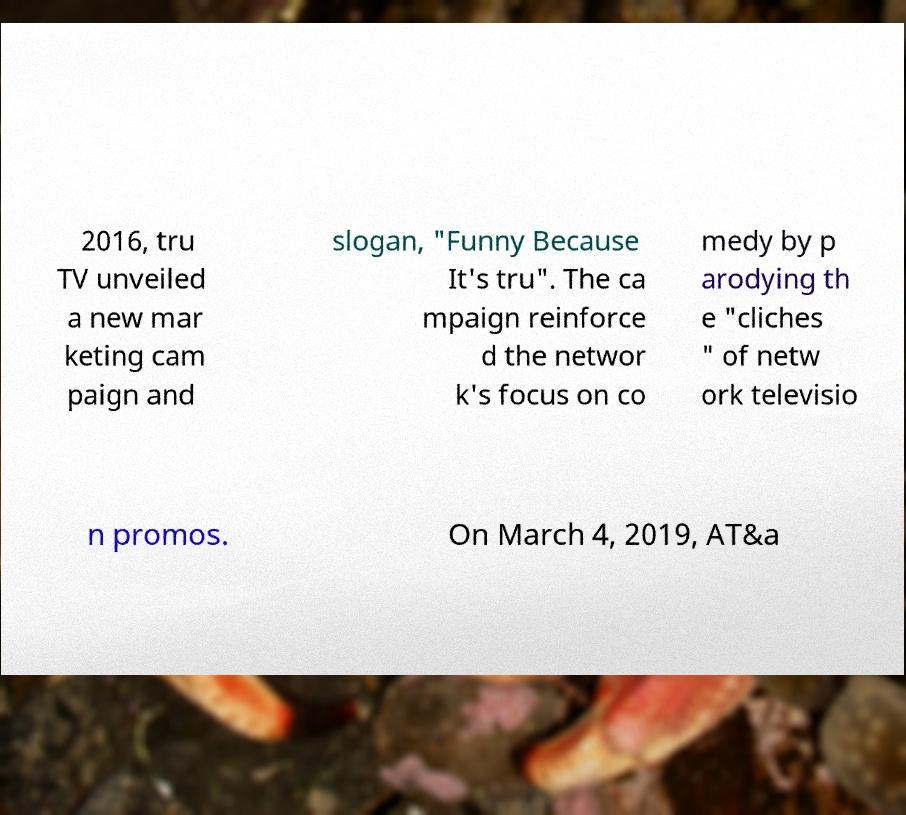Could you extract and type out the text from this image? 2016, tru TV unveiled a new mar keting cam paign and slogan, "Funny Because It's tru". The ca mpaign reinforce d the networ k's focus on co medy by p arodying th e "cliches " of netw ork televisio n promos. On March 4, 2019, AT&a 